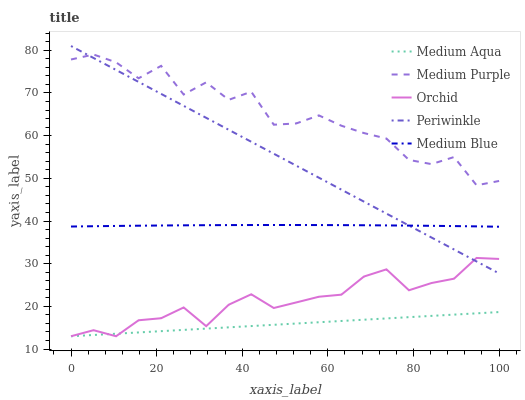Does Medium Aqua have the minimum area under the curve?
Answer yes or no. Yes. Does Medium Purple have the maximum area under the curve?
Answer yes or no. Yes. Does Periwinkle have the minimum area under the curve?
Answer yes or no. No. Does Periwinkle have the maximum area under the curve?
Answer yes or no. No. Is Medium Aqua the smoothest?
Answer yes or no. Yes. Is Medium Purple the roughest?
Answer yes or no. Yes. Is Periwinkle the smoothest?
Answer yes or no. No. Is Periwinkle the roughest?
Answer yes or no. No. Does Medium Aqua have the lowest value?
Answer yes or no. Yes. Does Periwinkle have the lowest value?
Answer yes or no. No. Does Periwinkle have the highest value?
Answer yes or no. Yes. Does Medium Aqua have the highest value?
Answer yes or no. No. Is Medium Aqua less than Periwinkle?
Answer yes or no. Yes. Is Medium Blue greater than Medium Aqua?
Answer yes or no. Yes. Does Periwinkle intersect Medium Blue?
Answer yes or no. Yes. Is Periwinkle less than Medium Blue?
Answer yes or no. No. Is Periwinkle greater than Medium Blue?
Answer yes or no. No. Does Medium Aqua intersect Periwinkle?
Answer yes or no. No. 